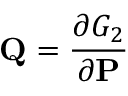<formula> <loc_0><loc_0><loc_500><loc_500>Q = { \frac { \partial G _ { 2 } } { \partial P } }</formula> 